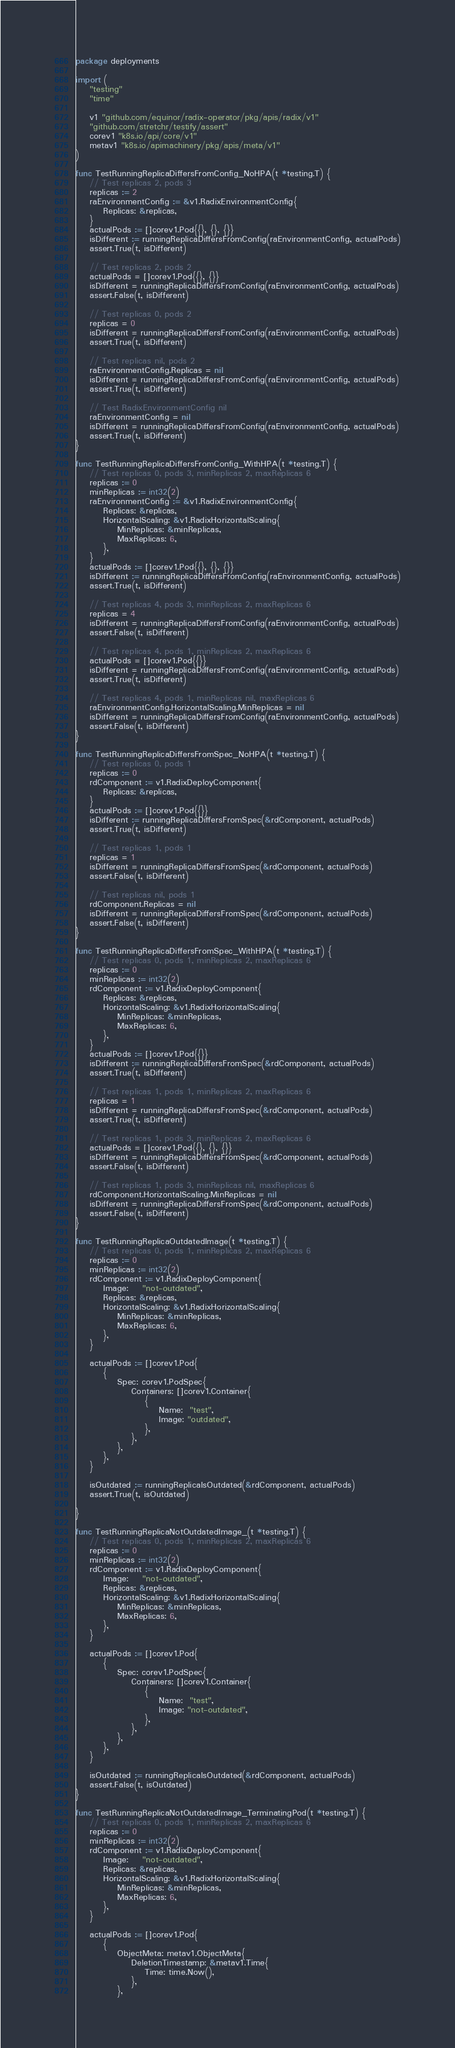Convert code to text. <code><loc_0><loc_0><loc_500><loc_500><_Go_>package deployments

import (
	"testing"
	"time"

	v1 "github.com/equinor/radix-operator/pkg/apis/radix/v1"
	"github.com/stretchr/testify/assert"
	corev1 "k8s.io/api/core/v1"
	metav1 "k8s.io/apimachinery/pkg/apis/meta/v1"
)

func TestRunningReplicaDiffersFromConfig_NoHPA(t *testing.T) {
	// Test replicas 2, pods 3
	replicas := 2
	raEnvironmentConfig := &v1.RadixEnvironmentConfig{
		Replicas: &replicas,
	}
	actualPods := []corev1.Pod{{}, {}, {}}
	isDifferent := runningReplicaDiffersFromConfig(raEnvironmentConfig, actualPods)
	assert.True(t, isDifferent)

	// Test replicas 2, pods 2
	actualPods = []corev1.Pod{{}, {}}
	isDifferent = runningReplicaDiffersFromConfig(raEnvironmentConfig, actualPods)
	assert.False(t, isDifferent)

	// Test replicas 0, pods 2
	replicas = 0
	isDifferent = runningReplicaDiffersFromConfig(raEnvironmentConfig, actualPods)
	assert.True(t, isDifferent)

	// Test replicas nil, pods 2
	raEnvironmentConfig.Replicas = nil
	isDifferent = runningReplicaDiffersFromConfig(raEnvironmentConfig, actualPods)
	assert.True(t, isDifferent)

	// Test RadixEnvironmentConfig nil
	raEnvironmentConfig = nil
	isDifferent = runningReplicaDiffersFromConfig(raEnvironmentConfig, actualPods)
	assert.True(t, isDifferent)
}

func TestRunningReplicaDiffersFromConfig_WithHPA(t *testing.T) {
	// Test replicas 0, pods 3, minReplicas 2, maxReplicas 6
	replicas := 0
	minReplicas := int32(2)
	raEnvironmentConfig := &v1.RadixEnvironmentConfig{
		Replicas: &replicas,
		HorizontalScaling: &v1.RadixHorizontalScaling{
			MinReplicas: &minReplicas,
			MaxReplicas: 6,
		},
	}
	actualPods := []corev1.Pod{{}, {}, {}}
	isDifferent := runningReplicaDiffersFromConfig(raEnvironmentConfig, actualPods)
	assert.True(t, isDifferent)

	// Test replicas 4, pods 3, minReplicas 2, maxReplicas 6
	replicas = 4
	isDifferent = runningReplicaDiffersFromConfig(raEnvironmentConfig, actualPods)
	assert.False(t, isDifferent)

	// Test replicas 4, pods 1, minReplicas 2, maxReplicas 6
	actualPods = []corev1.Pod{{}}
	isDifferent = runningReplicaDiffersFromConfig(raEnvironmentConfig, actualPods)
	assert.True(t, isDifferent)

	// Test replicas 4, pods 1, minReplicas nil, maxReplicas 6
	raEnvironmentConfig.HorizontalScaling.MinReplicas = nil
	isDifferent = runningReplicaDiffersFromConfig(raEnvironmentConfig, actualPods)
	assert.False(t, isDifferent)
}

func TestRunningReplicaDiffersFromSpec_NoHPA(t *testing.T) {
	// Test replicas 0, pods 1
	replicas := 0
	rdComponent := v1.RadixDeployComponent{
		Replicas: &replicas,
	}
	actualPods := []corev1.Pod{{}}
	isDifferent := runningReplicaDiffersFromSpec(&rdComponent, actualPods)
	assert.True(t, isDifferent)

	// Test replicas 1, pods 1
	replicas = 1
	isDifferent = runningReplicaDiffersFromSpec(&rdComponent, actualPods)
	assert.False(t, isDifferent)

	// Test replicas nil, pods 1
	rdComponent.Replicas = nil
	isDifferent = runningReplicaDiffersFromSpec(&rdComponent, actualPods)
	assert.False(t, isDifferent)
}

func TestRunningReplicaDiffersFromSpec_WithHPA(t *testing.T) {
	// Test replicas 0, pods 1, minReplicas 2, maxReplicas 6
	replicas := 0
	minReplicas := int32(2)
	rdComponent := v1.RadixDeployComponent{
		Replicas: &replicas,
		HorizontalScaling: &v1.RadixHorizontalScaling{
			MinReplicas: &minReplicas,
			MaxReplicas: 6,
		},
	}
	actualPods := []corev1.Pod{{}}
	isDifferent := runningReplicaDiffersFromSpec(&rdComponent, actualPods)
	assert.True(t, isDifferent)

	// Test replicas 1, pods 1, minReplicas 2, maxReplicas 6
	replicas = 1
	isDifferent = runningReplicaDiffersFromSpec(&rdComponent, actualPods)
	assert.True(t, isDifferent)

	// Test replicas 1, pods 3, minReplicas 2, maxReplicas 6
	actualPods = []corev1.Pod{{}, {}, {}}
	isDifferent = runningReplicaDiffersFromSpec(&rdComponent, actualPods)
	assert.False(t, isDifferent)

	// Test replicas 1, pods 3, minReplicas nil, maxReplicas 6
	rdComponent.HorizontalScaling.MinReplicas = nil
	isDifferent = runningReplicaDiffersFromSpec(&rdComponent, actualPods)
	assert.False(t, isDifferent)
}

func TestRunningReplicaOutdatedImage(t *testing.T) {
	// Test replicas 0, pods 1, minReplicas 2, maxReplicas 6
	replicas := 0
	minReplicas := int32(2)
	rdComponent := v1.RadixDeployComponent{
		Image:    "not-outdated",
		Replicas: &replicas,
		HorizontalScaling: &v1.RadixHorizontalScaling{
			MinReplicas: &minReplicas,
			MaxReplicas: 6,
		},
	}

	actualPods := []corev1.Pod{
		{
			Spec: corev1.PodSpec{
				Containers: []corev1.Container{
					{
						Name:  "test",
						Image: "outdated",
					},
				},
			},
		},
	}

	isOutdated := runningReplicaIsOutdated(&rdComponent, actualPods)
	assert.True(t, isOutdated)

}

func TestRunningReplicaNotOutdatedImage_(t *testing.T) {
	// Test replicas 0, pods 1, minReplicas 2, maxReplicas 6
	replicas := 0
	minReplicas := int32(2)
	rdComponent := v1.RadixDeployComponent{
		Image:    "not-outdated",
		Replicas: &replicas,
		HorizontalScaling: &v1.RadixHorizontalScaling{
			MinReplicas: &minReplicas,
			MaxReplicas: 6,
		},
	}

	actualPods := []corev1.Pod{
		{
			Spec: corev1.PodSpec{
				Containers: []corev1.Container{
					{
						Name:  "test",
						Image: "not-outdated",
					},
				},
			},
		},
	}

	isOutdated := runningReplicaIsOutdated(&rdComponent, actualPods)
	assert.False(t, isOutdated)
}

func TestRunningReplicaNotOutdatedImage_TerminatingPod(t *testing.T) {
	// Test replicas 0, pods 1, minReplicas 2, maxReplicas 6
	replicas := 0
	minReplicas := int32(2)
	rdComponent := v1.RadixDeployComponent{
		Image:    "not-outdated",
		Replicas: &replicas,
		HorizontalScaling: &v1.RadixHorizontalScaling{
			MinReplicas: &minReplicas,
			MaxReplicas: 6,
		},
	}

	actualPods := []corev1.Pod{
		{
			ObjectMeta: metav1.ObjectMeta{
				DeletionTimestamp: &metav1.Time{
					Time: time.Now(),
				},
			},</code> 